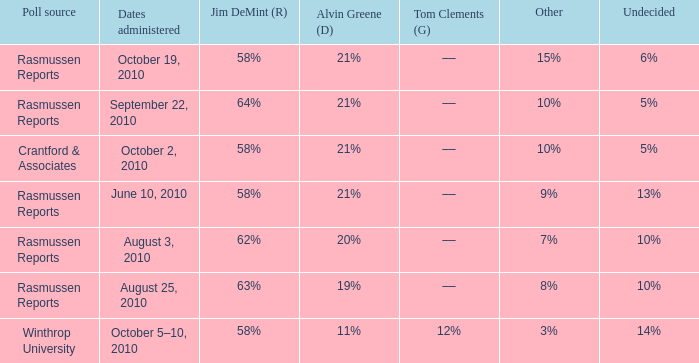Which poll source determined undecided of 5% and Jim DeMint (R) of 58%? Crantford & Associates. 